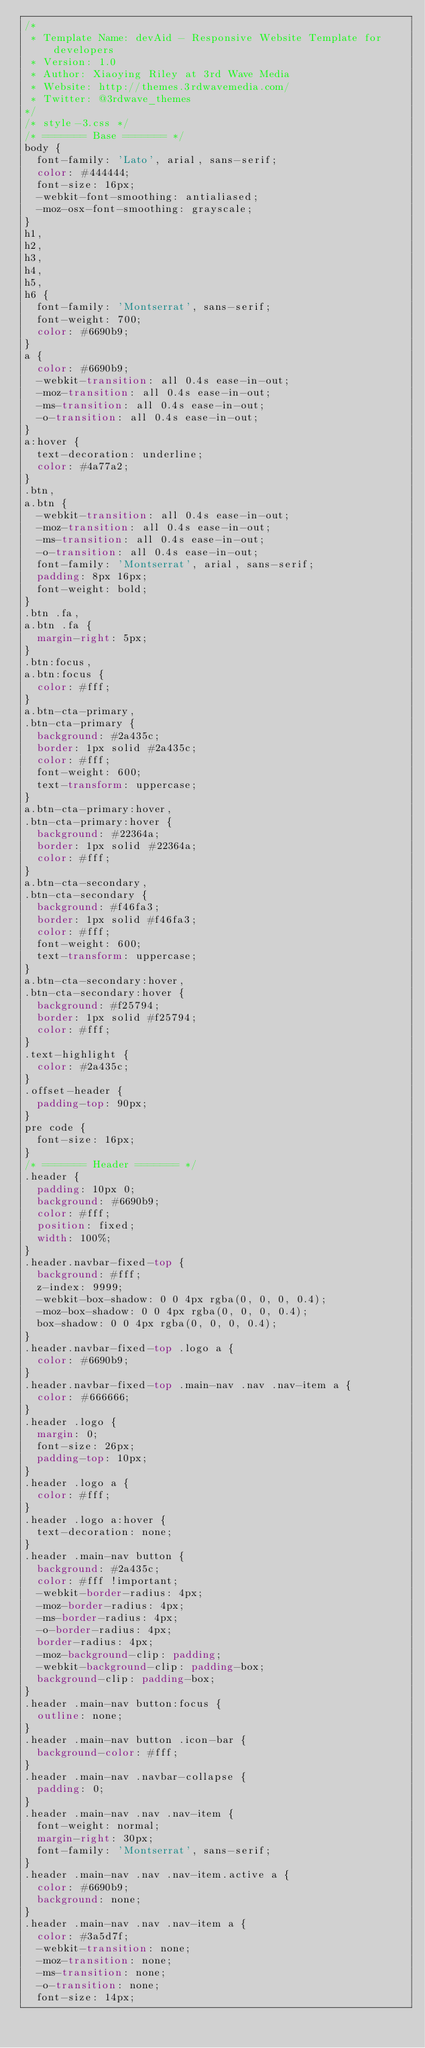Convert code to text. <code><loc_0><loc_0><loc_500><loc_500><_CSS_>/*   
 * Template Name: devAid - Responsive Website Template for developers
 * Version: 1.0
 * Author: Xiaoying Riley at 3rd Wave Media
 * Website: http://themes.3rdwavemedia.com/
 * Twitter: @3rdwave_themes
*/
/* style-3.css */
/* ======= Base ======= */
body {
  font-family: 'Lato', arial, sans-serif;
  color: #444444;
  font-size: 16px;
  -webkit-font-smoothing: antialiased;
  -moz-osx-font-smoothing: grayscale;
}
h1,
h2,
h3,
h4,
h5,
h6 {
  font-family: 'Montserrat', sans-serif;
  font-weight: 700;
  color: #6690b9;
}
a {
  color: #6690b9;
  -webkit-transition: all 0.4s ease-in-out;
  -moz-transition: all 0.4s ease-in-out;
  -ms-transition: all 0.4s ease-in-out;
  -o-transition: all 0.4s ease-in-out;
}
a:hover {
  text-decoration: underline;
  color: #4a77a2;
}
.btn,
a.btn {
  -webkit-transition: all 0.4s ease-in-out;
  -moz-transition: all 0.4s ease-in-out;
  -ms-transition: all 0.4s ease-in-out;
  -o-transition: all 0.4s ease-in-out;
  font-family: 'Montserrat', arial, sans-serif;
  padding: 8px 16px;
  font-weight: bold;
}
.btn .fa,
a.btn .fa {
  margin-right: 5px;
}
.btn:focus,
a.btn:focus {
  color: #fff;
}
a.btn-cta-primary,
.btn-cta-primary {
  background: #2a435c;
  border: 1px solid #2a435c;
  color: #fff;
  font-weight: 600;
  text-transform: uppercase;
}
a.btn-cta-primary:hover,
.btn-cta-primary:hover {
  background: #22364a;
  border: 1px solid #22364a;
  color: #fff;
}
a.btn-cta-secondary,
.btn-cta-secondary {
  background: #f46fa3;
  border: 1px solid #f46fa3;
  color: #fff;
  font-weight: 600;
  text-transform: uppercase;
}
a.btn-cta-secondary:hover,
.btn-cta-secondary:hover {
  background: #f25794;
  border: 1px solid #f25794;
  color: #fff;
}
.text-highlight {
  color: #2a435c;
}
.offset-header {
  padding-top: 90px;
}
pre code {
  font-size: 16px;
}
/* ======= Header ======= */
.header {
  padding: 10px 0;
  background: #6690b9;
  color: #fff;
  position: fixed;
  width: 100%;
}
.header.navbar-fixed-top {
  background: #fff;
  z-index: 9999;
  -webkit-box-shadow: 0 0 4px rgba(0, 0, 0, 0.4);
  -moz-box-shadow: 0 0 4px rgba(0, 0, 0, 0.4);
  box-shadow: 0 0 4px rgba(0, 0, 0, 0.4);
}
.header.navbar-fixed-top .logo a {
  color: #6690b9;
}
.header.navbar-fixed-top .main-nav .nav .nav-item a {
  color: #666666;
}
.header .logo {
  margin: 0;
  font-size: 26px;
  padding-top: 10px;
}
.header .logo a {
  color: #fff;
}
.header .logo a:hover {
  text-decoration: none;
}
.header .main-nav button {
  background: #2a435c;
  color: #fff !important;
  -webkit-border-radius: 4px;
  -moz-border-radius: 4px;
  -ms-border-radius: 4px;
  -o-border-radius: 4px;
  border-radius: 4px;
  -moz-background-clip: padding;
  -webkit-background-clip: padding-box;
  background-clip: padding-box;
}
.header .main-nav button:focus {
  outline: none;
}
.header .main-nav button .icon-bar {
  background-color: #fff;
}
.header .main-nav .navbar-collapse {
  padding: 0;
}
.header .main-nav .nav .nav-item {
  font-weight: normal;
  margin-right: 30px;
  font-family: 'Montserrat', sans-serif;
}
.header .main-nav .nav .nav-item.active a {
  color: #6690b9;
  background: none;
}
.header .main-nav .nav .nav-item a {
  color: #3a5d7f;
  -webkit-transition: none;
  -moz-transition: none;
  -ms-transition: none;
  -o-transition: none;
  font-size: 14px;</code> 